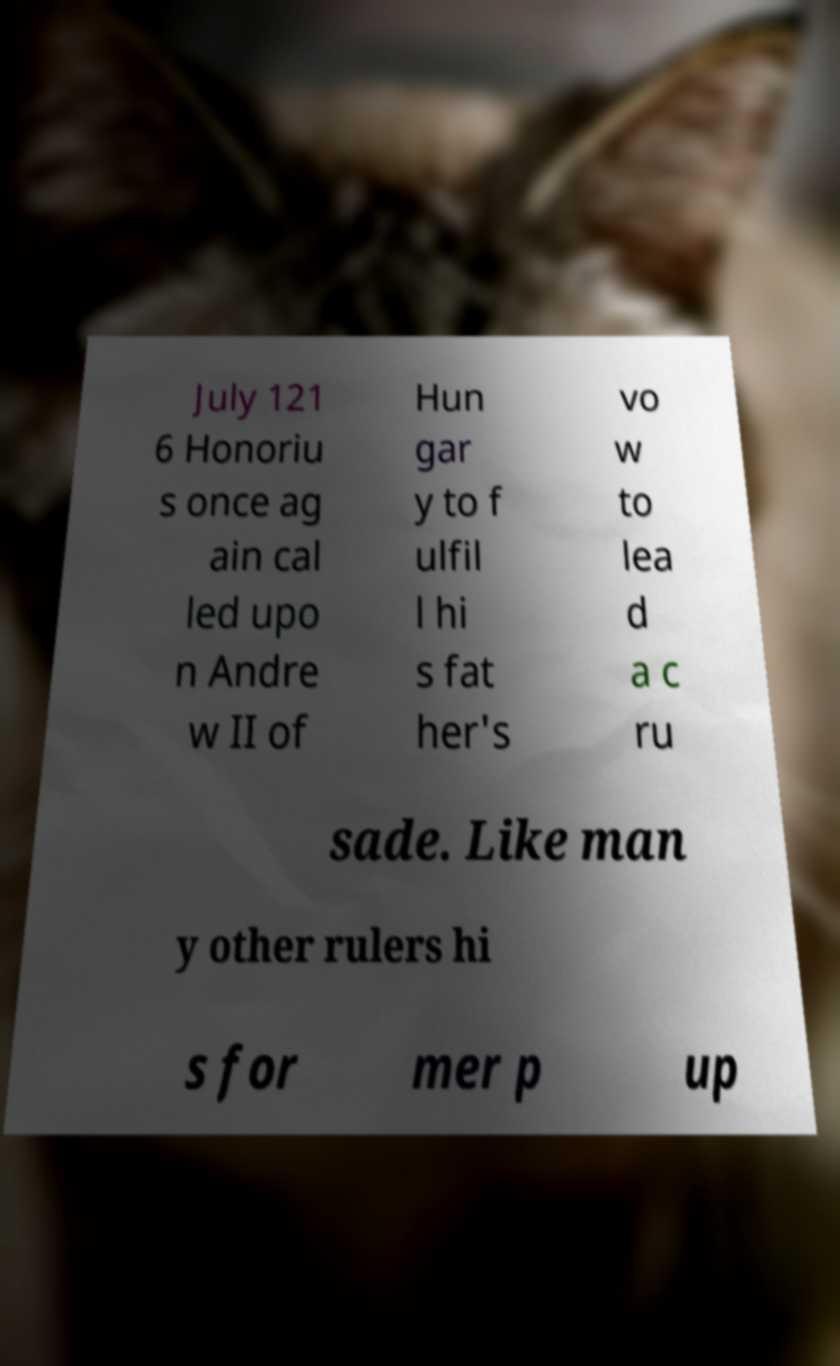Could you assist in decoding the text presented in this image and type it out clearly? July 121 6 Honoriu s once ag ain cal led upo n Andre w II of Hun gar y to f ulfil l hi s fat her's vo w to lea d a c ru sade. Like man y other rulers hi s for mer p up 